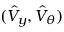Convert formula to latex. <formula><loc_0><loc_0><loc_500><loc_500>( \hat { V } _ { y } , \hat { V } _ { \theta } )</formula> 